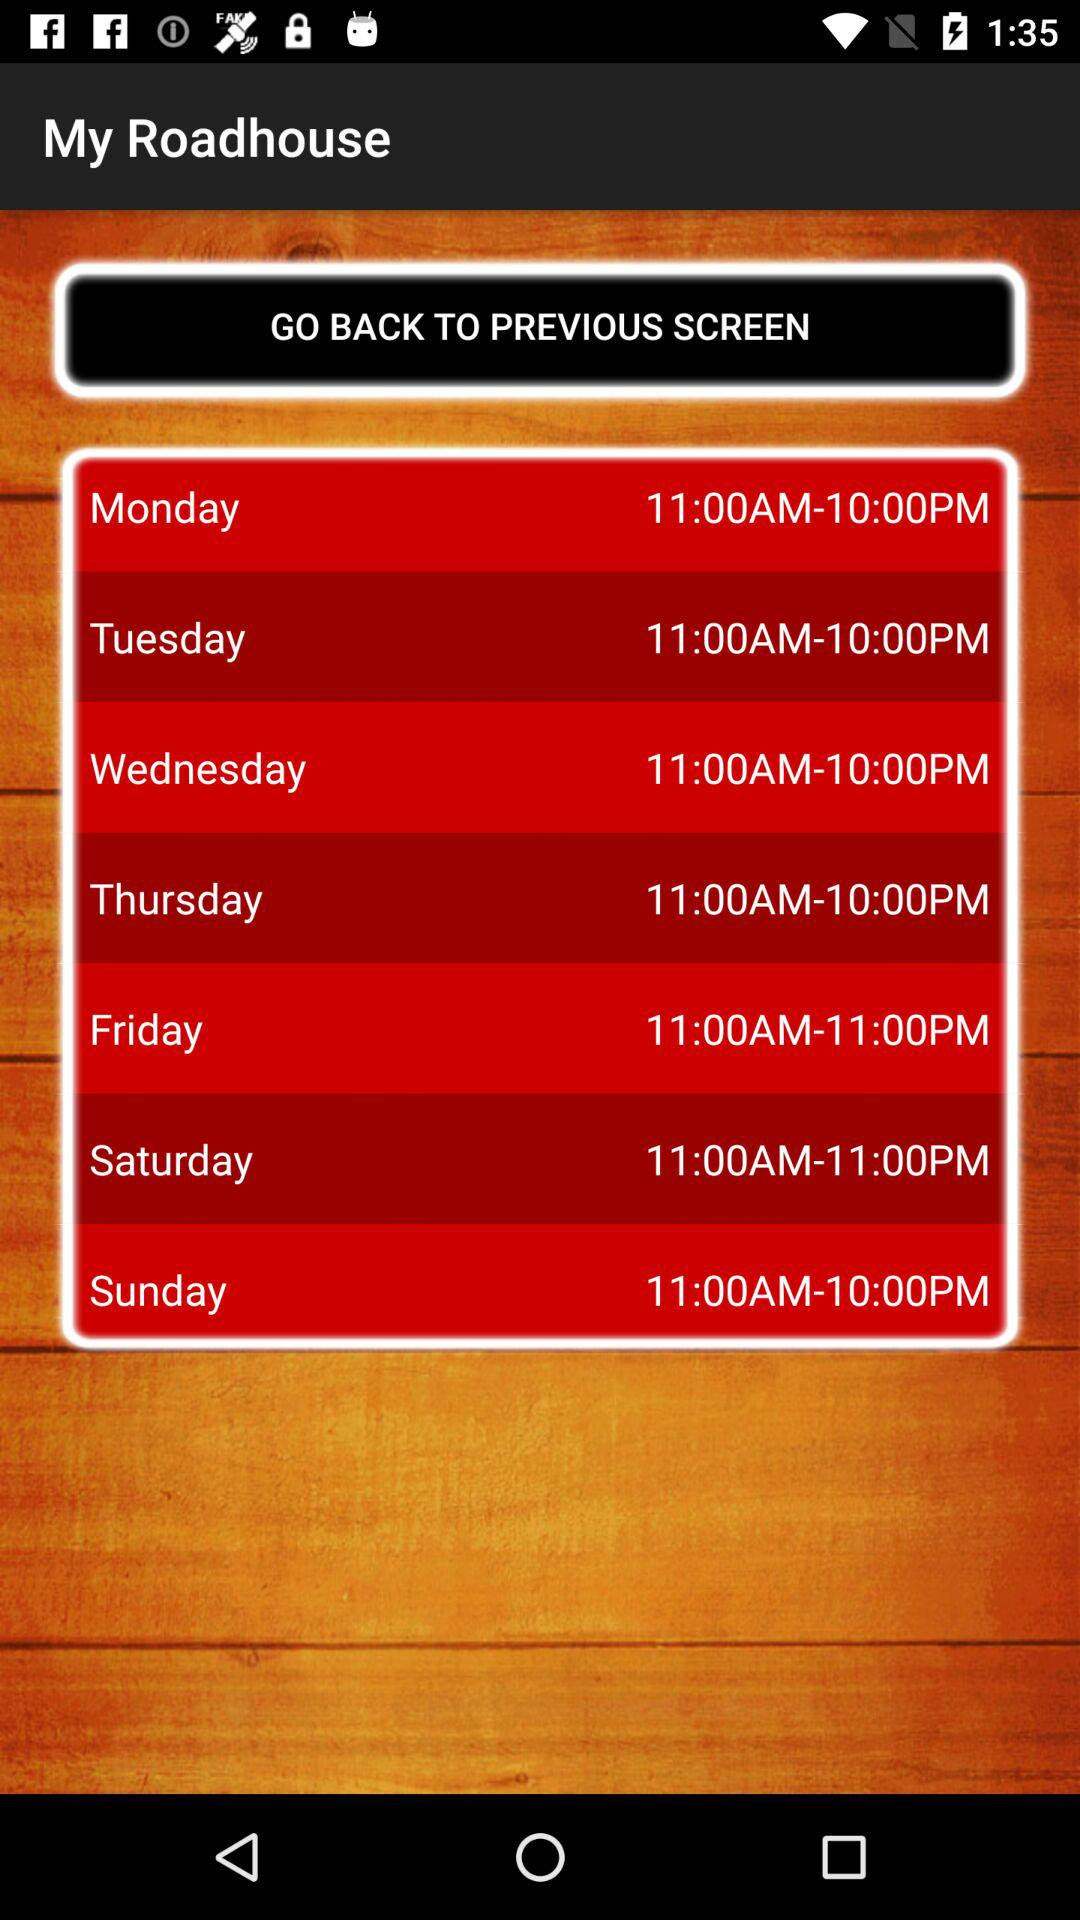What is the given time duration for Monday? The time duration is from 11 a.m. to 10 p.m. 